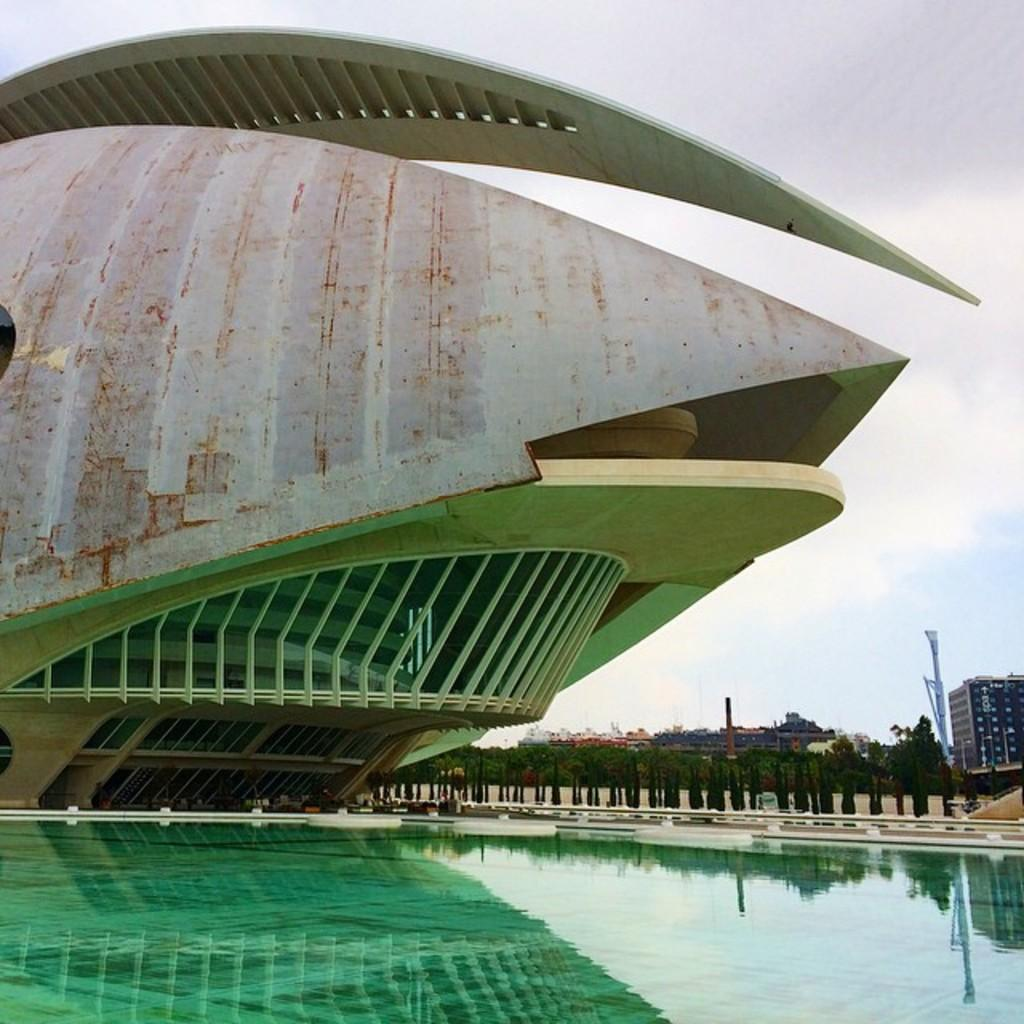What is the main subject in the center of the image? There is a building in the center of the image. What can be seen at the bottom of the image? There is water visible at the bottom of the image. What is visible in the background of the image? There are buildings, trees, poles, and the sky visible in the background of the image. What is the condition of the sky in the image? Clouds are present in the sky. Can you tell me how many snails are crawling on the table in the image? There is no table or snails present in the image. What color is the eye of the person in the image? There are no people or eyes visible in the image. 